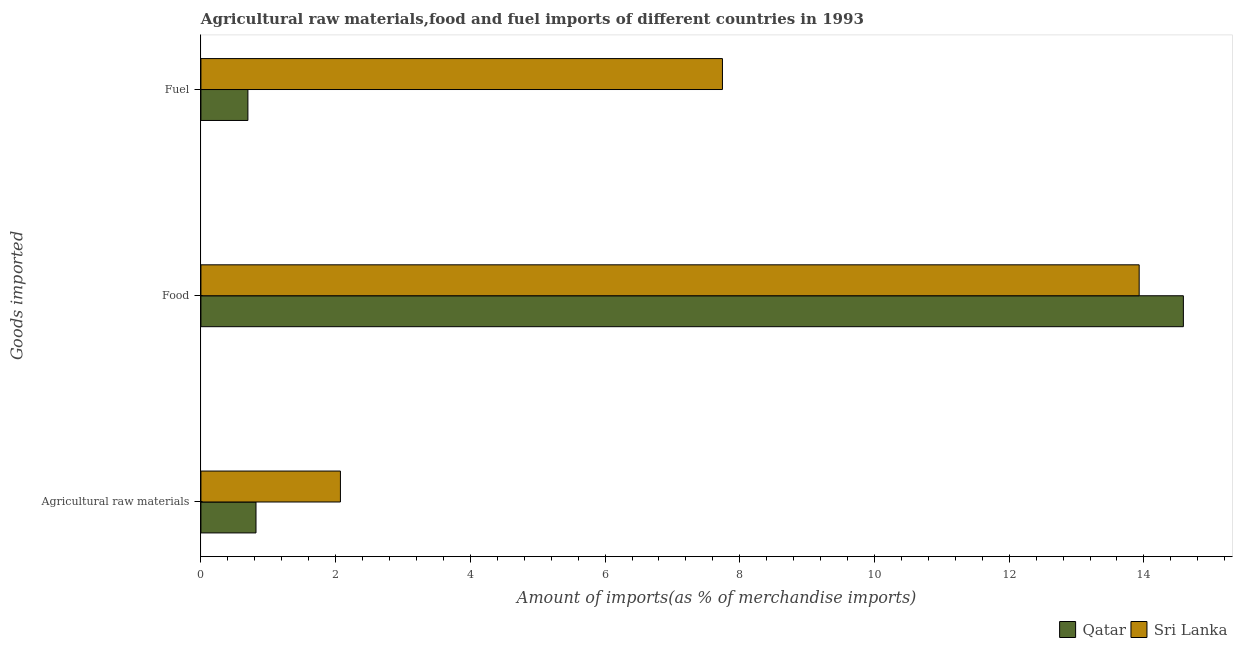How many different coloured bars are there?
Ensure brevity in your answer.  2. How many groups of bars are there?
Ensure brevity in your answer.  3. Are the number of bars per tick equal to the number of legend labels?
Offer a very short reply. Yes. Are the number of bars on each tick of the Y-axis equal?
Provide a short and direct response. Yes. What is the label of the 3rd group of bars from the top?
Your answer should be very brief. Agricultural raw materials. What is the percentage of raw materials imports in Sri Lanka?
Your response must be concise. 2.07. Across all countries, what is the maximum percentage of food imports?
Your answer should be very brief. 14.59. Across all countries, what is the minimum percentage of food imports?
Give a very brief answer. 13.93. In which country was the percentage of fuel imports maximum?
Offer a very short reply. Sri Lanka. In which country was the percentage of raw materials imports minimum?
Provide a short and direct response. Qatar. What is the total percentage of fuel imports in the graph?
Your response must be concise. 8.44. What is the difference between the percentage of food imports in Sri Lanka and that in Qatar?
Ensure brevity in your answer.  -0.66. What is the difference between the percentage of raw materials imports in Qatar and the percentage of food imports in Sri Lanka?
Offer a very short reply. -13.11. What is the average percentage of food imports per country?
Give a very brief answer. 14.26. What is the difference between the percentage of raw materials imports and percentage of fuel imports in Qatar?
Your answer should be very brief. 0.12. In how many countries, is the percentage of raw materials imports greater than 7.2 %?
Offer a very short reply. 0. What is the ratio of the percentage of food imports in Qatar to that in Sri Lanka?
Your response must be concise. 1.05. Is the difference between the percentage of food imports in Sri Lanka and Qatar greater than the difference between the percentage of raw materials imports in Sri Lanka and Qatar?
Offer a very short reply. No. What is the difference between the highest and the second highest percentage of food imports?
Your response must be concise. 0.66. What is the difference between the highest and the lowest percentage of food imports?
Give a very brief answer. 0.66. Is the sum of the percentage of food imports in Sri Lanka and Qatar greater than the maximum percentage of raw materials imports across all countries?
Your answer should be compact. Yes. What does the 2nd bar from the top in Fuel represents?
Ensure brevity in your answer.  Qatar. What does the 2nd bar from the bottom in Food represents?
Keep it short and to the point. Sri Lanka. Is it the case that in every country, the sum of the percentage of raw materials imports and percentage of food imports is greater than the percentage of fuel imports?
Offer a terse response. Yes. Are all the bars in the graph horizontal?
Offer a terse response. Yes. How many countries are there in the graph?
Provide a short and direct response. 2. How are the legend labels stacked?
Keep it short and to the point. Horizontal. What is the title of the graph?
Your answer should be very brief. Agricultural raw materials,food and fuel imports of different countries in 1993. What is the label or title of the X-axis?
Ensure brevity in your answer.  Amount of imports(as % of merchandise imports). What is the label or title of the Y-axis?
Offer a terse response. Goods imported. What is the Amount of imports(as % of merchandise imports) in Qatar in Agricultural raw materials?
Make the answer very short. 0.82. What is the Amount of imports(as % of merchandise imports) in Sri Lanka in Agricultural raw materials?
Your answer should be very brief. 2.07. What is the Amount of imports(as % of merchandise imports) of Qatar in Food?
Your answer should be compact. 14.59. What is the Amount of imports(as % of merchandise imports) in Sri Lanka in Food?
Offer a very short reply. 13.93. What is the Amount of imports(as % of merchandise imports) of Qatar in Fuel?
Give a very brief answer. 0.7. What is the Amount of imports(as % of merchandise imports) of Sri Lanka in Fuel?
Make the answer very short. 7.74. Across all Goods imported, what is the maximum Amount of imports(as % of merchandise imports) of Qatar?
Provide a succinct answer. 14.59. Across all Goods imported, what is the maximum Amount of imports(as % of merchandise imports) in Sri Lanka?
Ensure brevity in your answer.  13.93. Across all Goods imported, what is the minimum Amount of imports(as % of merchandise imports) of Qatar?
Make the answer very short. 0.7. Across all Goods imported, what is the minimum Amount of imports(as % of merchandise imports) in Sri Lanka?
Offer a very short reply. 2.07. What is the total Amount of imports(as % of merchandise imports) of Qatar in the graph?
Your answer should be very brief. 16.1. What is the total Amount of imports(as % of merchandise imports) in Sri Lanka in the graph?
Give a very brief answer. 23.74. What is the difference between the Amount of imports(as % of merchandise imports) of Qatar in Agricultural raw materials and that in Food?
Give a very brief answer. -13.77. What is the difference between the Amount of imports(as % of merchandise imports) in Sri Lanka in Agricultural raw materials and that in Food?
Provide a succinct answer. -11.86. What is the difference between the Amount of imports(as % of merchandise imports) of Qatar in Agricultural raw materials and that in Fuel?
Your answer should be very brief. 0.12. What is the difference between the Amount of imports(as % of merchandise imports) of Sri Lanka in Agricultural raw materials and that in Fuel?
Offer a very short reply. -5.67. What is the difference between the Amount of imports(as % of merchandise imports) in Qatar in Food and that in Fuel?
Your answer should be very brief. 13.89. What is the difference between the Amount of imports(as % of merchandise imports) in Sri Lanka in Food and that in Fuel?
Give a very brief answer. 6.19. What is the difference between the Amount of imports(as % of merchandise imports) of Qatar in Agricultural raw materials and the Amount of imports(as % of merchandise imports) of Sri Lanka in Food?
Offer a terse response. -13.11. What is the difference between the Amount of imports(as % of merchandise imports) of Qatar in Agricultural raw materials and the Amount of imports(as % of merchandise imports) of Sri Lanka in Fuel?
Offer a very short reply. -6.93. What is the difference between the Amount of imports(as % of merchandise imports) in Qatar in Food and the Amount of imports(as % of merchandise imports) in Sri Lanka in Fuel?
Keep it short and to the point. 6.84. What is the average Amount of imports(as % of merchandise imports) of Qatar per Goods imported?
Make the answer very short. 5.37. What is the average Amount of imports(as % of merchandise imports) of Sri Lanka per Goods imported?
Ensure brevity in your answer.  7.91. What is the difference between the Amount of imports(as % of merchandise imports) in Qatar and Amount of imports(as % of merchandise imports) in Sri Lanka in Agricultural raw materials?
Offer a terse response. -1.25. What is the difference between the Amount of imports(as % of merchandise imports) in Qatar and Amount of imports(as % of merchandise imports) in Sri Lanka in Food?
Give a very brief answer. 0.66. What is the difference between the Amount of imports(as % of merchandise imports) of Qatar and Amount of imports(as % of merchandise imports) of Sri Lanka in Fuel?
Ensure brevity in your answer.  -7.05. What is the ratio of the Amount of imports(as % of merchandise imports) in Qatar in Agricultural raw materials to that in Food?
Keep it short and to the point. 0.06. What is the ratio of the Amount of imports(as % of merchandise imports) of Sri Lanka in Agricultural raw materials to that in Food?
Keep it short and to the point. 0.15. What is the ratio of the Amount of imports(as % of merchandise imports) of Qatar in Agricultural raw materials to that in Fuel?
Give a very brief answer. 1.17. What is the ratio of the Amount of imports(as % of merchandise imports) of Sri Lanka in Agricultural raw materials to that in Fuel?
Make the answer very short. 0.27. What is the ratio of the Amount of imports(as % of merchandise imports) in Qatar in Food to that in Fuel?
Offer a very short reply. 20.91. What is the ratio of the Amount of imports(as % of merchandise imports) of Sri Lanka in Food to that in Fuel?
Keep it short and to the point. 1.8. What is the difference between the highest and the second highest Amount of imports(as % of merchandise imports) of Qatar?
Your answer should be very brief. 13.77. What is the difference between the highest and the second highest Amount of imports(as % of merchandise imports) in Sri Lanka?
Keep it short and to the point. 6.19. What is the difference between the highest and the lowest Amount of imports(as % of merchandise imports) in Qatar?
Give a very brief answer. 13.89. What is the difference between the highest and the lowest Amount of imports(as % of merchandise imports) in Sri Lanka?
Your response must be concise. 11.86. 